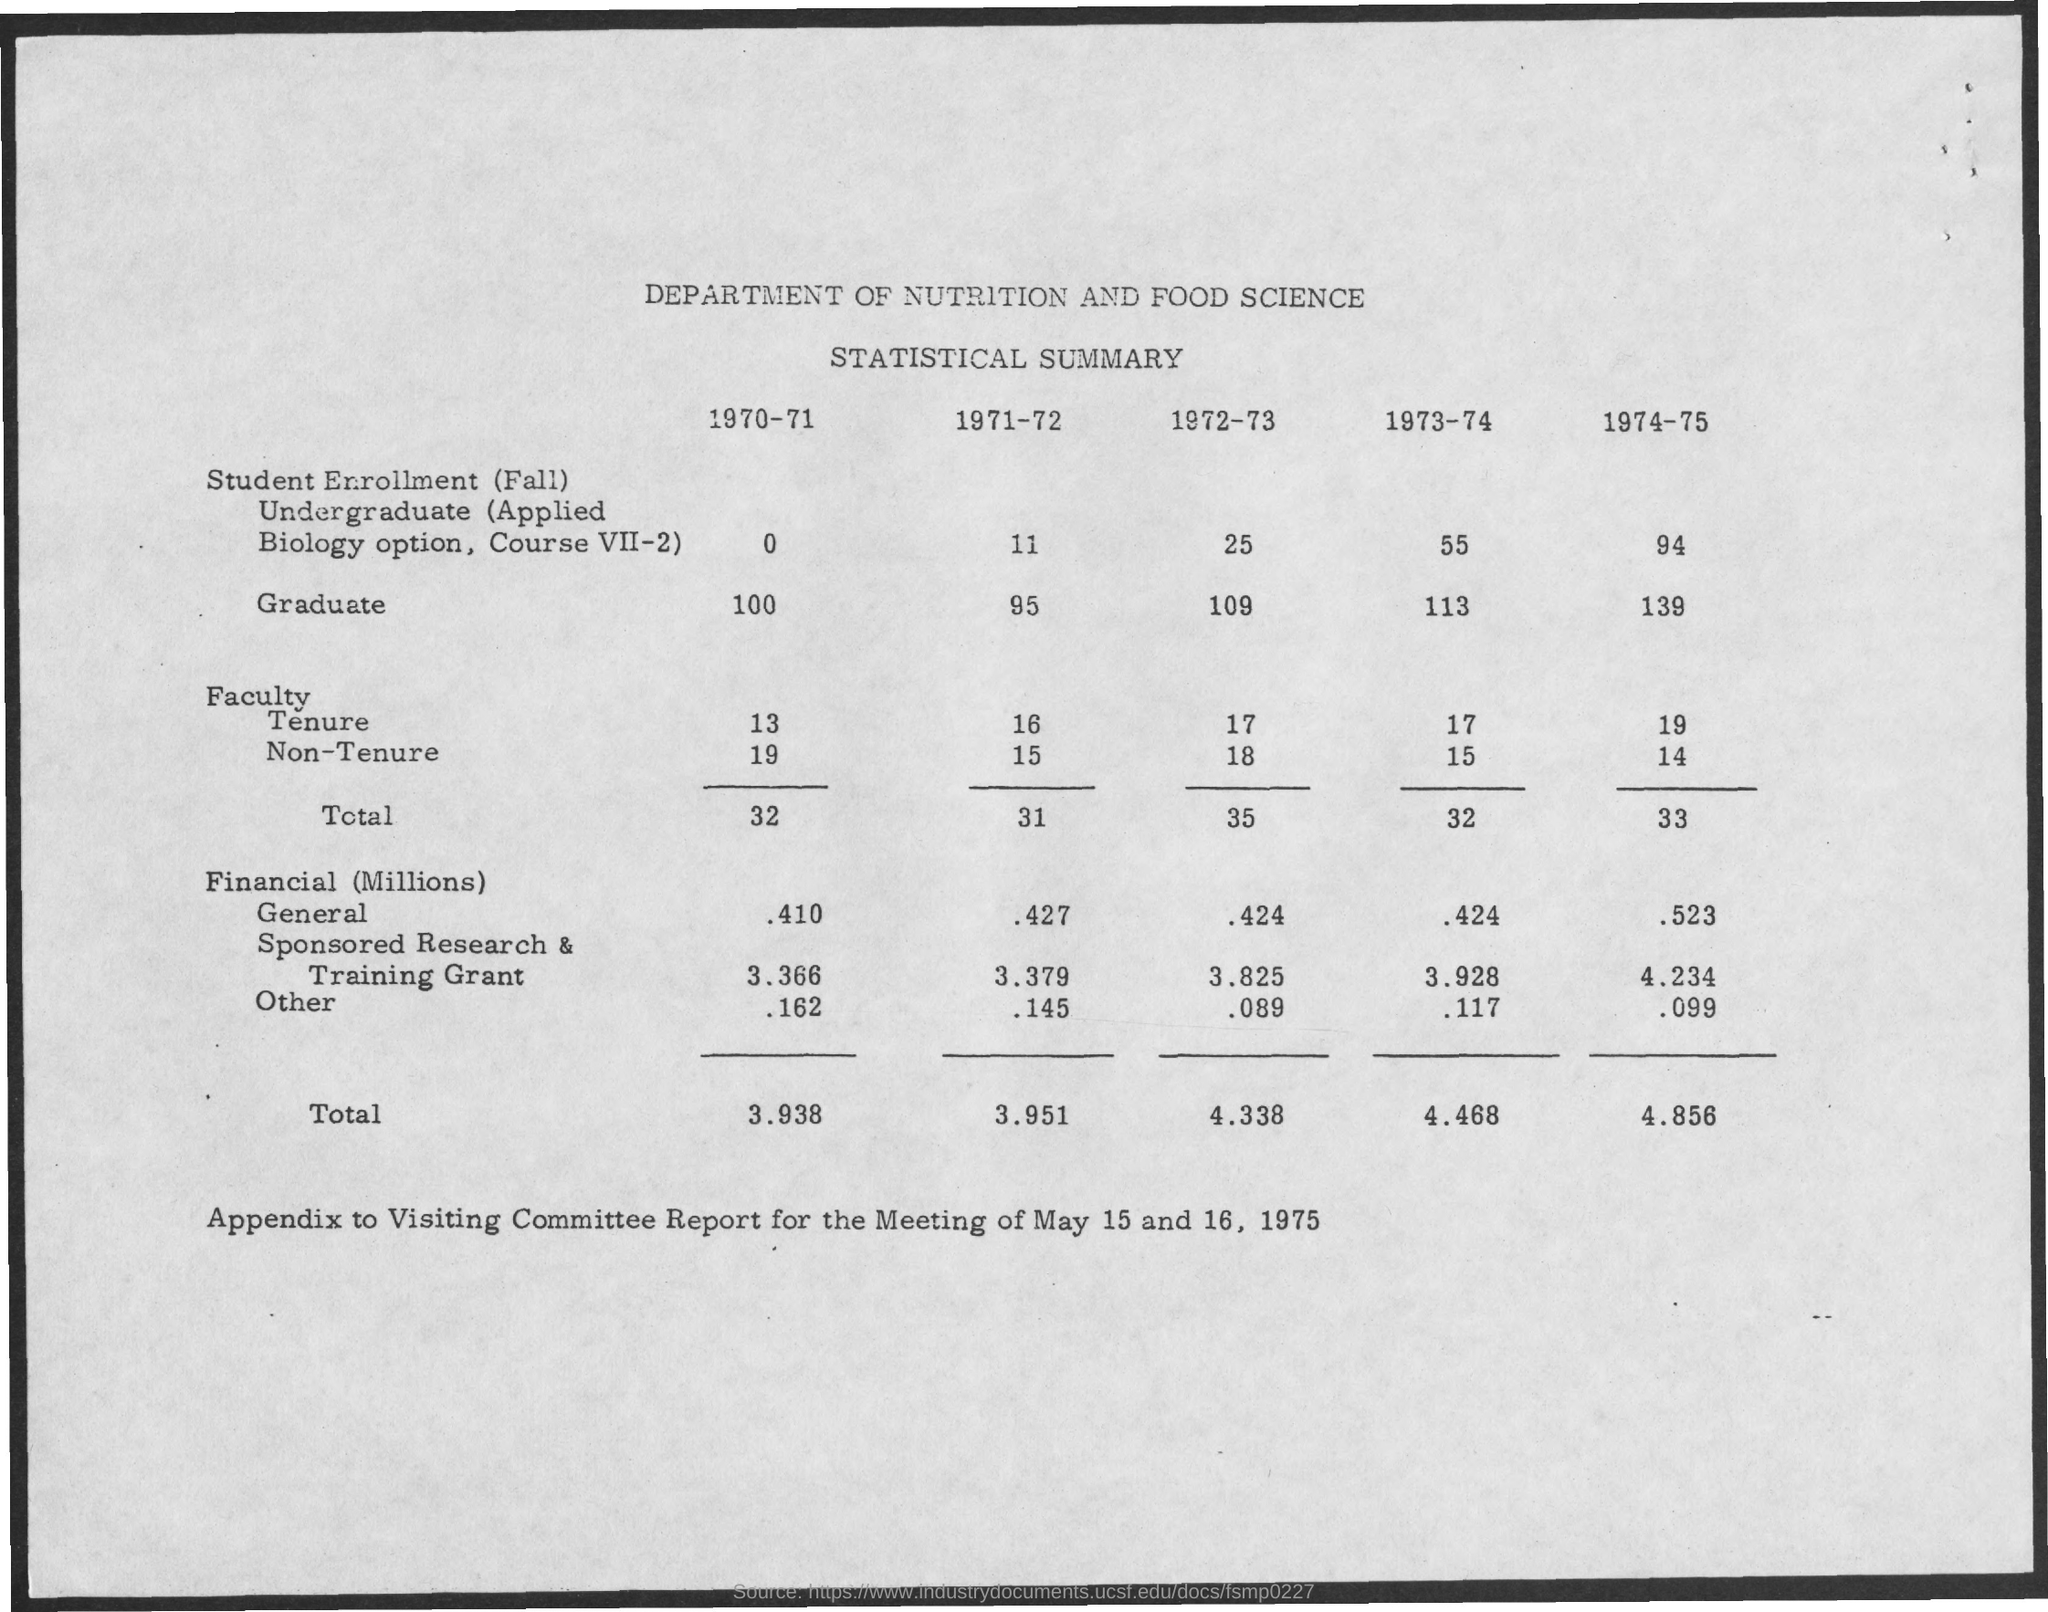Draw attention to some important aspects in this diagram. The total cost of the faculty for the academic year 1972-1973 is 35.. The financial total for 1970-71 was 3.938. The Department of Nutrition and Food Science is the correct department. The data is a statistical summary. 